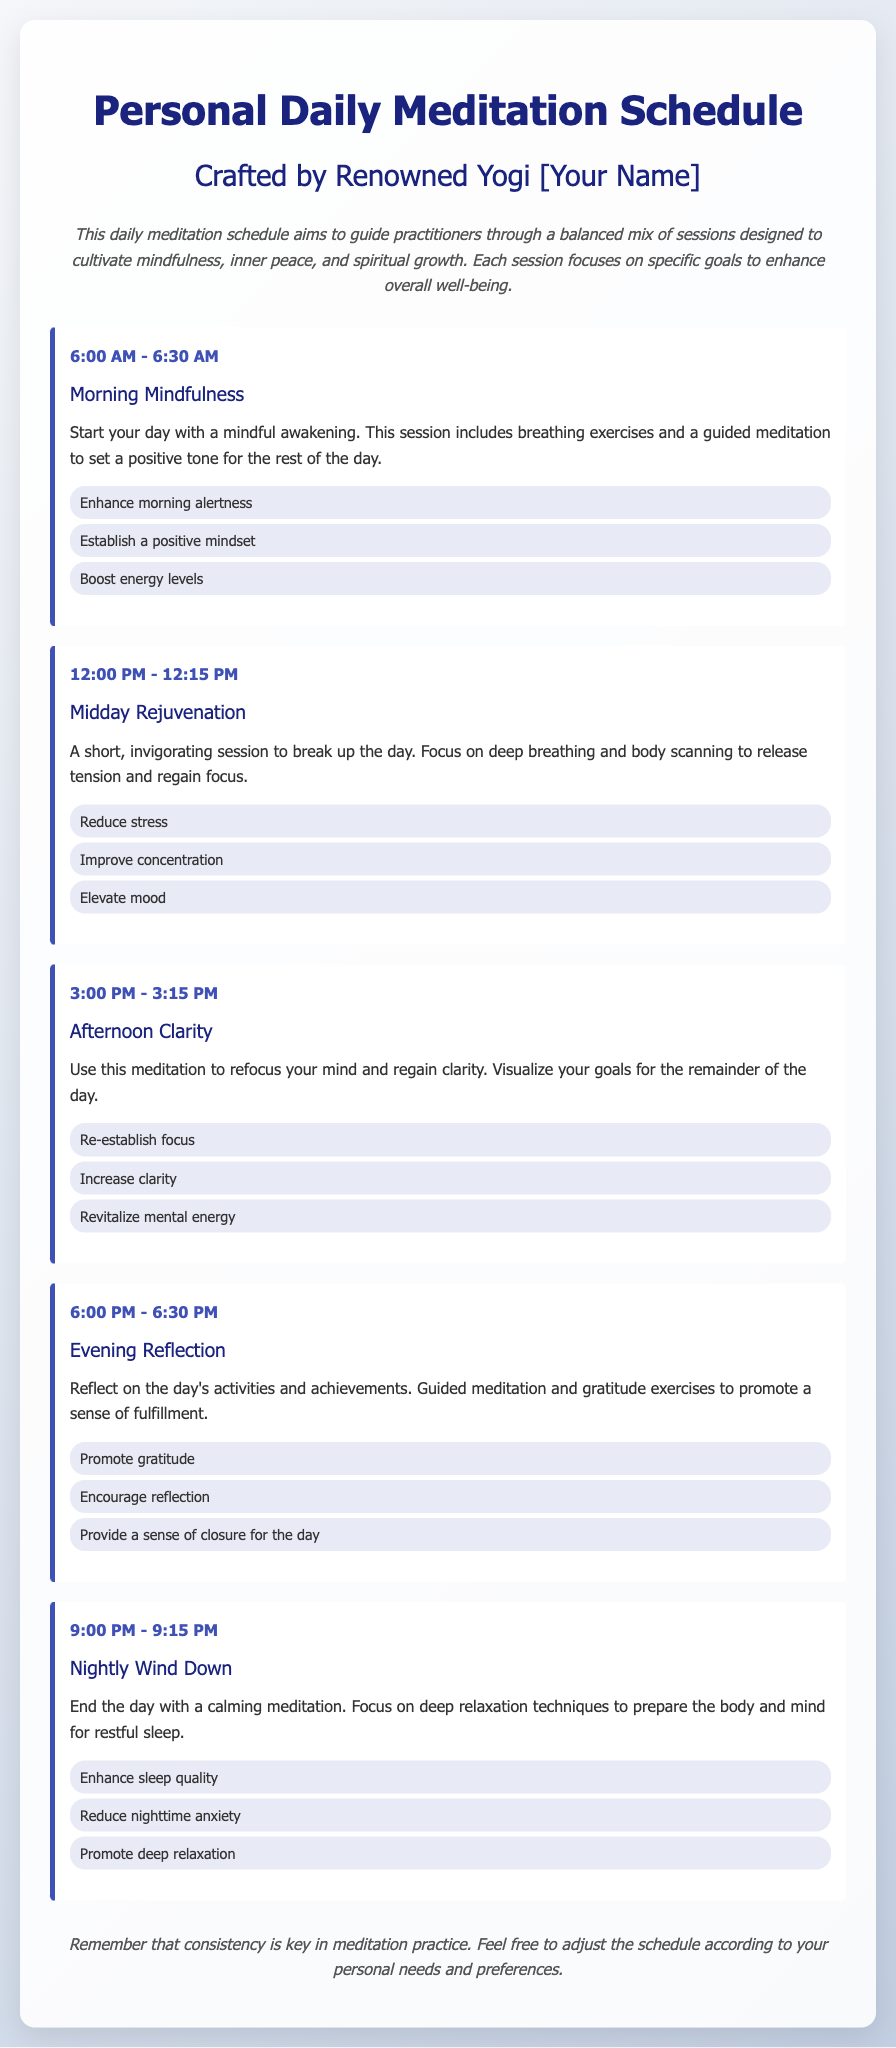What time is the Morning Mindfulness session? The Morning Mindfulness session is scheduled from 6:00 AM to 6:30 AM.
Answer: 6:00 AM - 6:30 AM What is the goal of the Nightly Wind Down session? The Nightly Wind Down session has goals including enhancing sleep quality, reducing nighttime anxiety, and promoting deep relaxation.
Answer: Enhance sleep quality How long does the Afternoon Clarity session last? The Afternoon Clarity session is scheduled for 15 minutes, from 3:00 PM to 3:15 PM.
Answer: 15 minutes What activity is included in the Evening Reflection session? The Evening Reflection session includes reflecting on the day's activities and achievements and gratitude exercises.
Answer: Reflect on the day's activities How many total meditation sessions are listed in the schedule? There are five distinct meditation sessions mentioned in the schedule.
Answer: Five What is the primary focus of the Midday Rejuvenation session? The Midday Rejuvenation session focuses on deep breathing and body scanning to release tension.
Answer: Deep breathing What is the style of the document? The document presents a personal daily meditation schedule that is crafted in an organized manner with specific session details.
Answer: Organized and structured What should practitioners remember about meditation according to the document? Practitioners should remember that consistency is key in meditation practice.
Answer: Consistency is key 